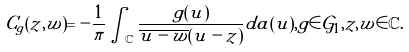<formula> <loc_0><loc_0><loc_500><loc_500>C _ { g } ( z , w ) = - \frac { 1 } { \pi } \int _ { \mathbb { C } } \frac { g ( u ) } { \overline { u - w } ( u - z ) } d a ( u ) , g \in \mathcal { G } _ { 1 } , z , w \in \mathbb { C } .</formula> 